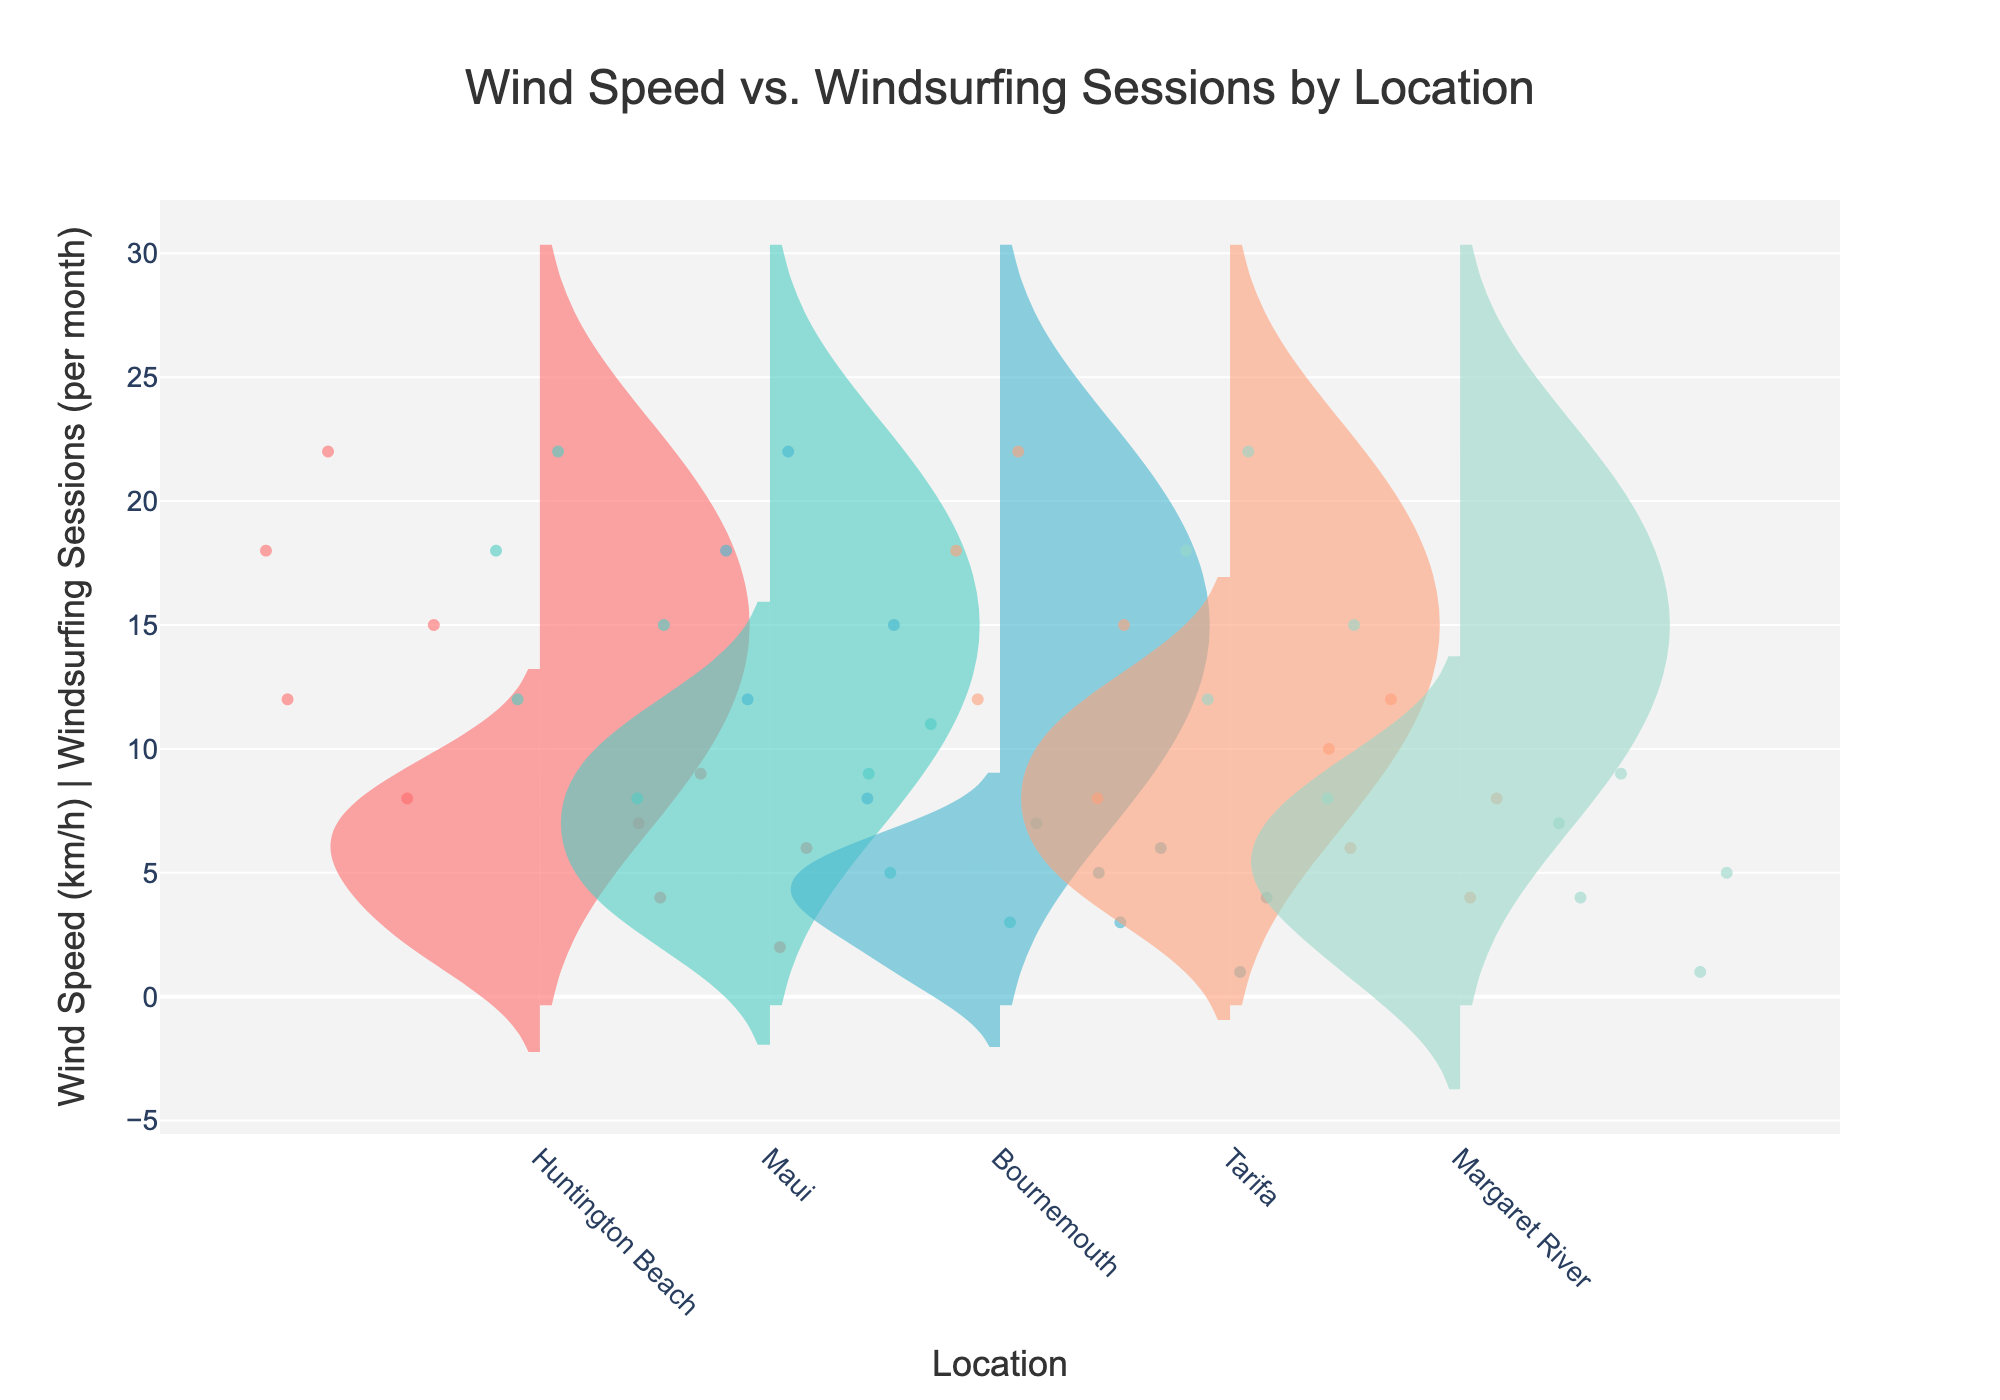What is the title of the chart? The title is located at the top of the chart and provides a summary of the data displayed. The title reads "Wind Speed vs. Windsurfing Sessions by Location."
Answer: Wind Speed vs. Windsurfing Sessions by Location Which location has the highest number of windsurfing sessions per month at a wind speed of 22 km/h? By looking at the negative side (left side) of each location for the point at 22 km/h, we can see the number of windsurfing sessions. Tarifa has the highest number of sessions, which is 12 per month at that wind speed.
Answer: Tarifa How many windsurfing sessions does Bournemouth have at a wind speed of 12 km/h? By looking at the negative side (left side) of the Bournemouth violin plot for the point at 12 km/h, we count the number of windsurfing sessions, which is 3 per month.
Answer: 3 Which location has the widest spread of wind speeds? We look at the size of the positive side (right side) of each violin plot. Maui and Tarifa have the widest spread, each showing wind speeds ranging from 8 km/h to 22 km/h, but the spread appears to be most noticeable in Maui.
Answer: Maui Is the number of windsurfing sessions generally higher at locations with higher average wind speeds? By observing the trend in the negative side (left side) of the violin plots, locations like Tarifa and Maui, with higher wind speeds, tend to have more windsurfing sessions on average compared to places like Bournemouth and Margaret River.
Answer: Yes What is the average number of windsurfing sessions per month in Margaret River when the wind speed is 15 km/h? For Margaret River, look at the negative side (left side) of the plot at 15 km/h. The point shows the number of sessions, which is 5. This is a single data point, so the average is simply 5.
Answer: 5 Compare the number of windsurfing sessions in Huntington Beach and Maui at 18 km/h wind speed. Which location has more sessions? Look at the number of sessions (negative side) for both Huntington Beach and Maui at 18 km/h. Huntington Beach has 7 sessions, whereas Maui has 9 sessions.
Answer: Maui What is the common wind speed value that appears for all locations? By examining the x-axis value ranges and focusing on the positive sides (right side) of the violins, we see that all locations have data points at wind speeds of 8, 12, 15, 18, and 22 km/h.
Answer: 8, 12, 15, 18, 22 km/h In which location do windsurfing sessions increase linearly with wind speed? By visually inspecting the relationship between wind speed and windsurfing sessions (negative side) across each location, it appears that Tarifa shows a linear increase in sessions with increasing wind speeds.
Answer: Tarifa 